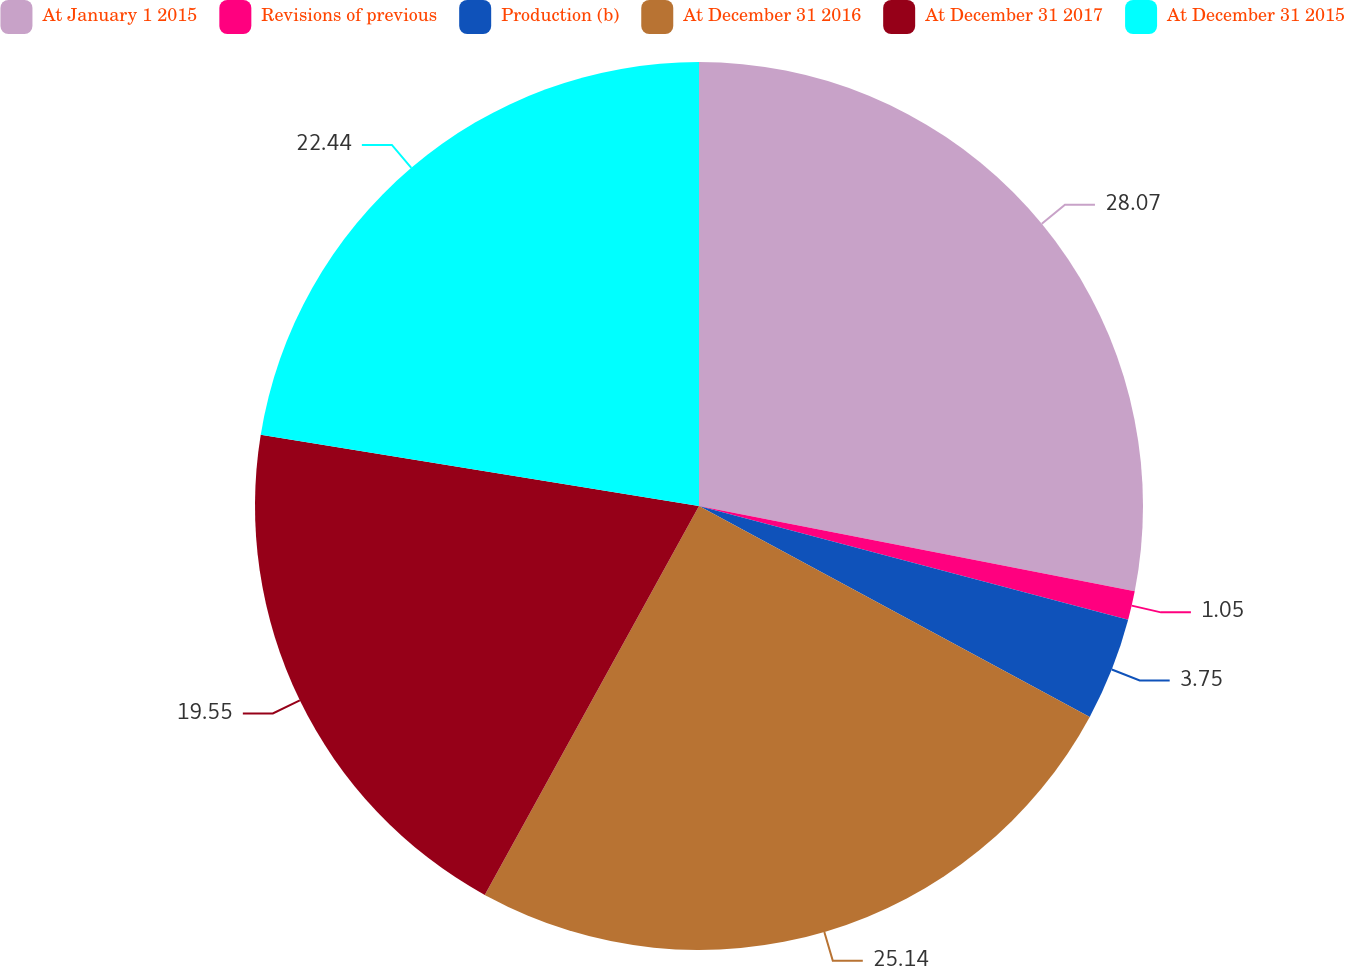Convert chart to OTSL. <chart><loc_0><loc_0><loc_500><loc_500><pie_chart><fcel>At January 1 2015<fcel>Revisions of previous<fcel>Production (b)<fcel>At December 31 2016<fcel>At December 31 2017<fcel>At December 31 2015<nl><fcel>28.08%<fcel>1.05%<fcel>3.75%<fcel>25.14%<fcel>19.55%<fcel>22.44%<nl></chart> 